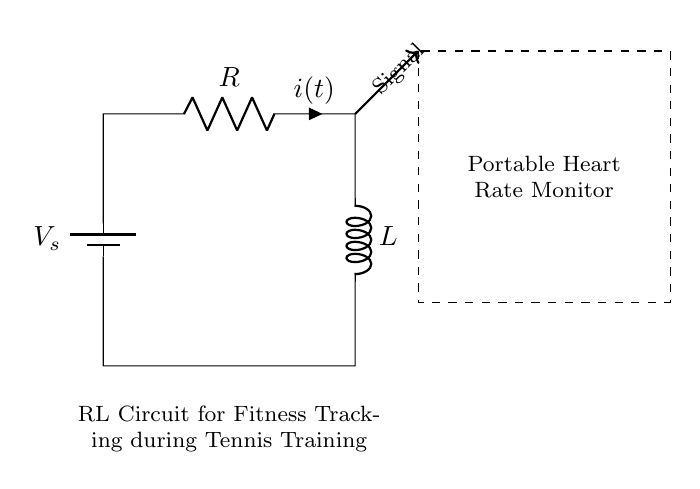What are the components used in this circuit? The circuit contains a resistor and an inductor. These components are standard elements in an RL circuit.
Answer: resistor and inductor What does the dashed rectangle represent? The dashed rectangle indicates the area where the portable heart rate monitor is located, suggesting its purpose in the circuit.
Answer: Portable Heart Rate Monitor What is the function of the power source in this circuit? The power source, represented by the battery, provides the necessary voltage required to drive the circuit and initiate the flow of current through it.
Answer: Provide voltage What is the current denoted as in this circuit? The current flowing through the resistor is denoted as 'i(t)', indicating that it is a time-dependent current as part of the RL circuit dynamics.
Answer: i(t) How does the inductor affect the current flow in this circuit? The inductor introduces a time-delay effect, causing the current to rise and fall gradually rather than instantaneously, which is a characteristic behavior of an RL circuit.
Answer: Delays current flow In a typical RL circuit, what happens when the switch is closed? Closing the switch allows current to flow through the circuit, causing the inductor to store energy in its magnetic field and increasing the current over time according to the time constant.
Answer: Current increases What would happen to the heart rate signal if the resistor value is increased? Increasing the resistor value leads to a greater voltage drop across the resistor, which can reduce the current through the inductor and thus diminish the strength of the heart rate signal detected.
Answer: Signal strength decreases 